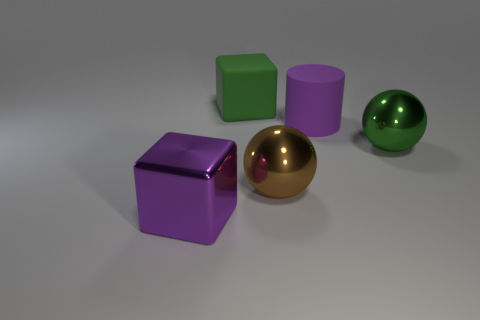Add 1 large cubes. How many objects exist? 6 Subtract 1 balls. How many balls are left? 1 Subtract all balls. How many objects are left? 3 Subtract all purple blocks. How many blocks are left? 1 Subtract all purple shiny objects. Subtract all large shiny cubes. How many objects are left? 3 Add 5 matte things. How many matte things are left? 7 Add 3 brown metallic balls. How many brown metallic balls exist? 4 Subtract 0 brown blocks. How many objects are left? 5 Subtract all blue cylinders. Subtract all green balls. How many cylinders are left? 1 Subtract all blue cubes. How many green cylinders are left? 0 